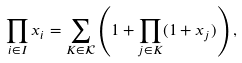Convert formula to latex. <formula><loc_0><loc_0><loc_500><loc_500>\prod _ { i \in I } x _ { i } = \sum _ { K \in \mathcal { K } } \left ( 1 + \prod _ { j \in K } ( 1 + x _ { j } ) \right ) ,</formula> 